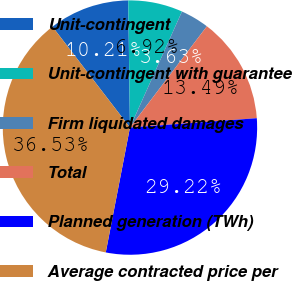Convert chart. <chart><loc_0><loc_0><loc_500><loc_500><pie_chart><fcel>Unit-contingent<fcel>Unit-contingent with guarantee<fcel>Firm liquidated damages<fcel>Total<fcel>Planned generation (TWh)<fcel>Average contracted price per<nl><fcel>10.21%<fcel>6.92%<fcel>3.63%<fcel>13.49%<fcel>29.22%<fcel>36.53%<nl></chart> 